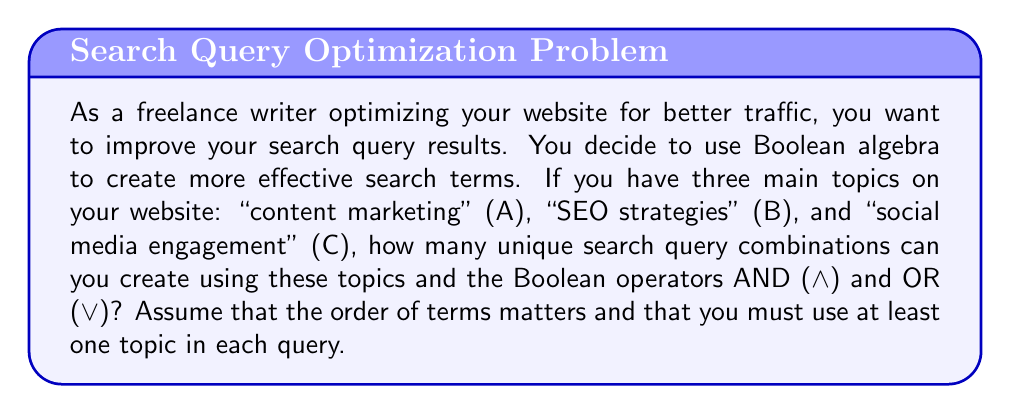Help me with this question. To solve this problem, we'll use the principles of Boolean algebra and combinatorics:

1) First, let's consider the possible ways to use each topic:
   - We can either include a topic or not include it.
   - This gives us 2 choices for each topic.

2) However, we must use at least one topic, so we can't have the case where no topics are used.

3) For each combination of topics, we need to consider the Boolean operators:
   - Between any two terms, we can use either AND ($\land$) or OR ($\lor$).
   - The number of operators needed is one less than the number of terms used.

4) Let's break it down by the number of topics used:

   a) Using 1 topic: $\binom{3}{1} = 3$ ways
      No operators needed.

   b) Using 2 topics: $\binom{3}{2} \cdot 2! = 6$ ways to choose and order topics
      1 operator needed, 2 choices: $6 \cdot 2 = 12$ combinations

   c) Using 3 topics: $3! = 6$ ways to order all topics
      2 operators needed, $2^2 = 4$ choices: $6 \cdot 4 = 24$ combinations

5) Total number of unique combinations:
   $3 + 12 + 24 = 39$

Therefore, you can create 39 unique search query combinations using these three topics and the Boolean operators AND and OR.
Answer: 39 unique search query combinations 